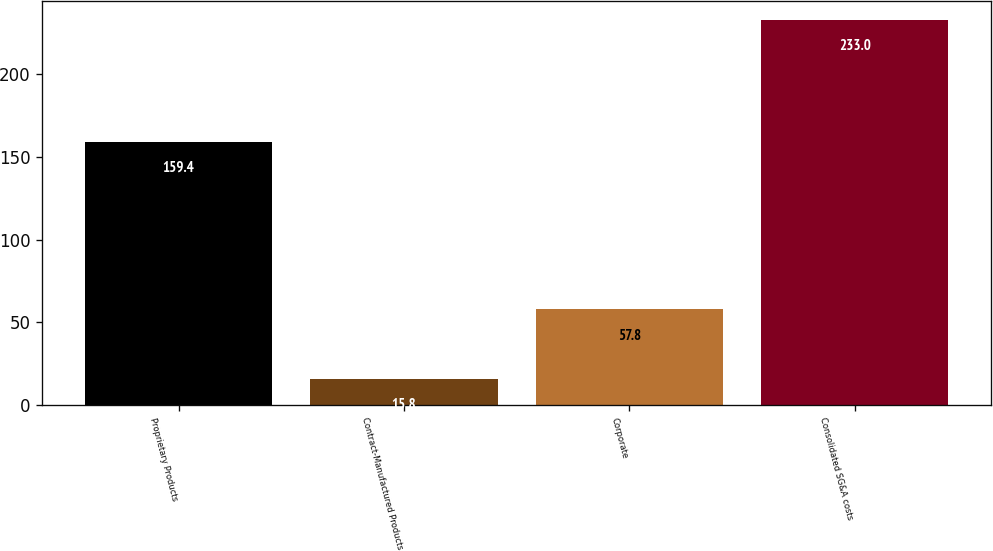<chart> <loc_0><loc_0><loc_500><loc_500><bar_chart><fcel>Proprietary Products<fcel>Contract-Manufactured Products<fcel>Corporate<fcel>Consolidated SG&A costs<nl><fcel>159.4<fcel>15.8<fcel>57.8<fcel>233<nl></chart> 